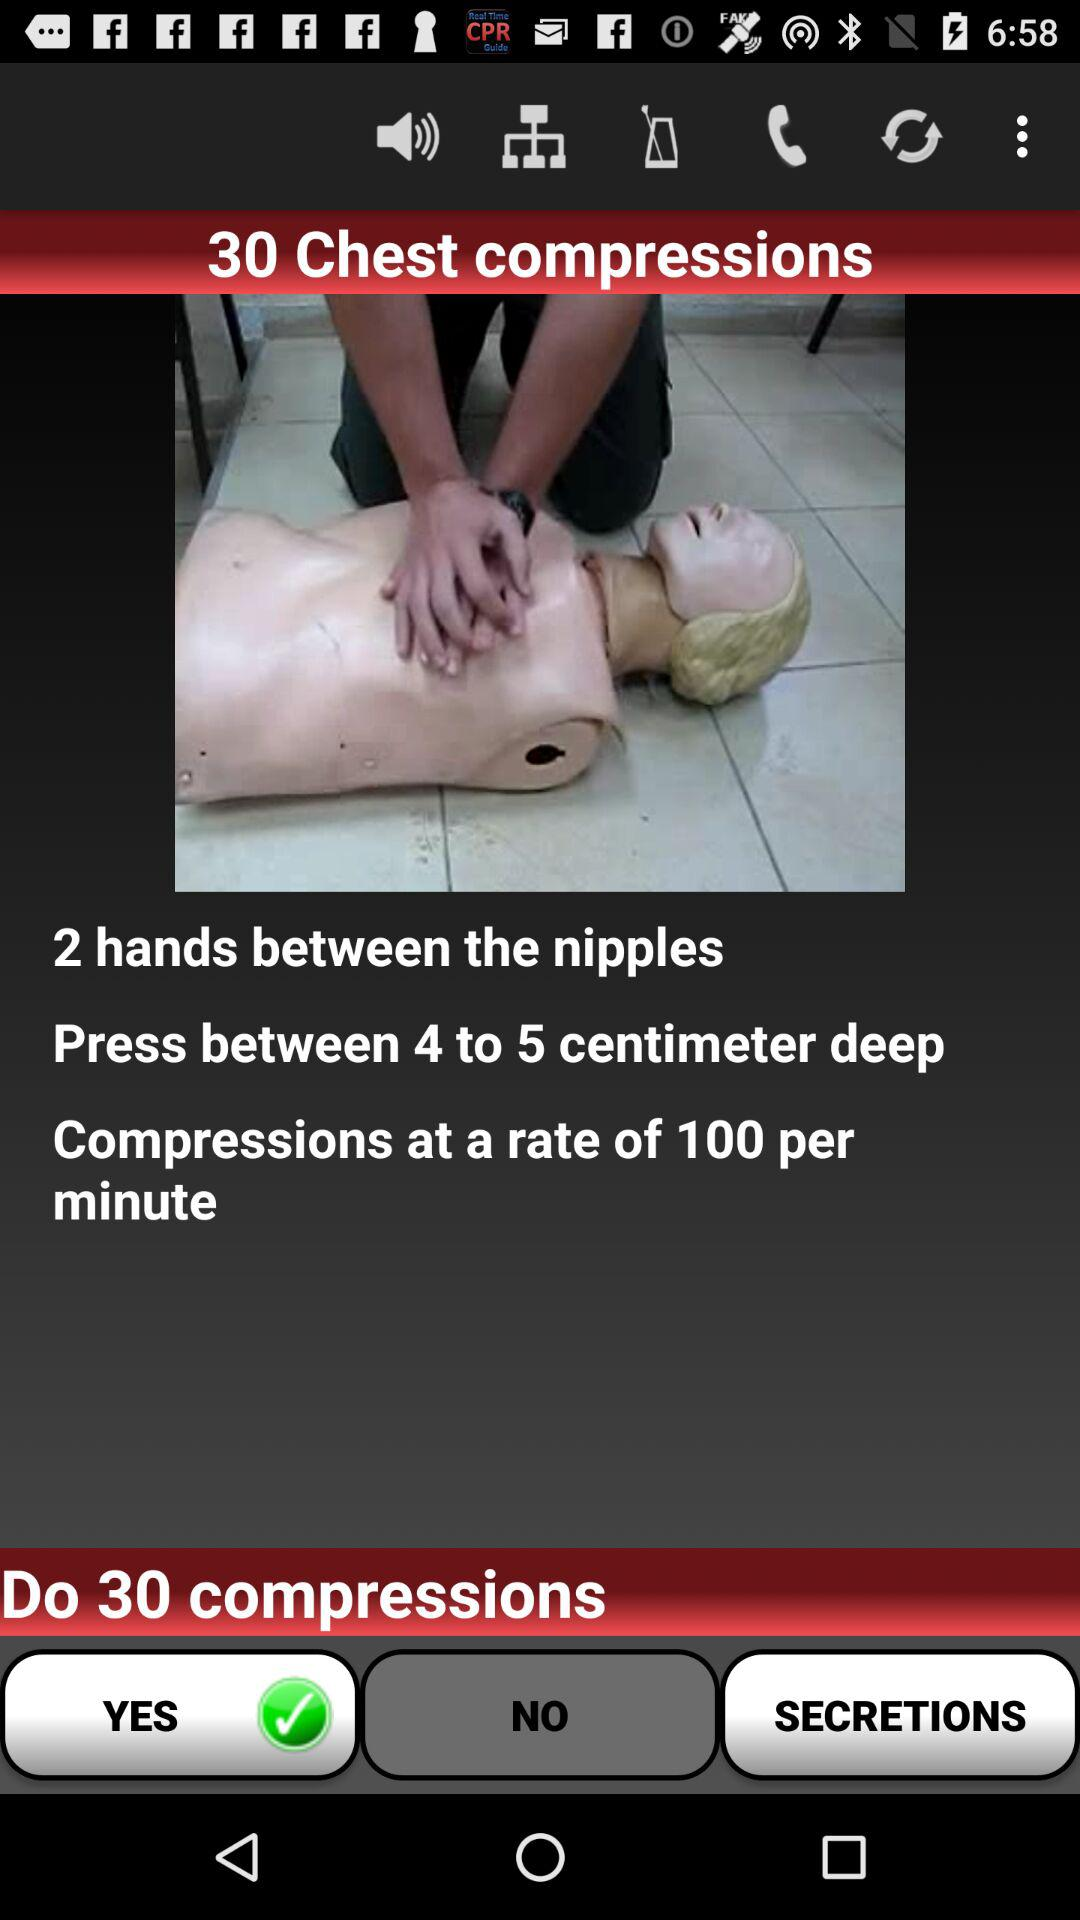What's the total number of chest compressions? The total number of chest compressions is 30. 